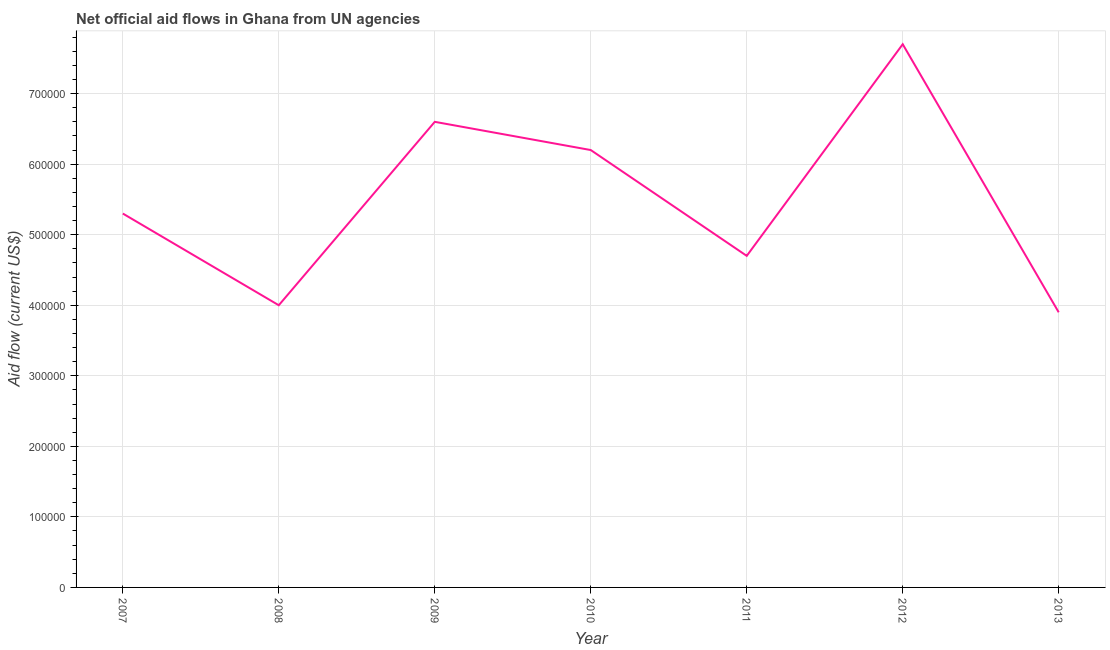What is the net official flows from un agencies in 2013?
Your response must be concise. 3.90e+05. Across all years, what is the maximum net official flows from un agencies?
Provide a short and direct response. 7.70e+05. Across all years, what is the minimum net official flows from un agencies?
Offer a terse response. 3.90e+05. In which year was the net official flows from un agencies maximum?
Provide a succinct answer. 2012. In which year was the net official flows from un agencies minimum?
Your answer should be compact. 2013. What is the sum of the net official flows from un agencies?
Your answer should be compact. 3.84e+06. What is the difference between the net official flows from un agencies in 2011 and 2013?
Offer a very short reply. 8.00e+04. What is the average net official flows from un agencies per year?
Your answer should be very brief. 5.49e+05. What is the median net official flows from un agencies?
Provide a short and direct response. 5.30e+05. What is the ratio of the net official flows from un agencies in 2009 to that in 2010?
Provide a short and direct response. 1.06. Is the net official flows from un agencies in 2007 less than that in 2010?
Your response must be concise. Yes. Is the difference between the net official flows from un agencies in 2009 and 2013 greater than the difference between any two years?
Offer a very short reply. No. What is the difference between the highest and the lowest net official flows from un agencies?
Give a very brief answer. 3.80e+05. In how many years, is the net official flows from un agencies greater than the average net official flows from un agencies taken over all years?
Offer a terse response. 3. Are the values on the major ticks of Y-axis written in scientific E-notation?
Make the answer very short. No. Does the graph contain any zero values?
Provide a succinct answer. No. Does the graph contain grids?
Provide a short and direct response. Yes. What is the title of the graph?
Give a very brief answer. Net official aid flows in Ghana from UN agencies. What is the label or title of the X-axis?
Your response must be concise. Year. What is the Aid flow (current US$) of 2007?
Give a very brief answer. 5.30e+05. What is the Aid flow (current US$) of 2008?
Your response must be concise. 4.00e+05. What is the Aid flow (current US$) in 2009?
Ensure brevity in your answer.  6.60e+05. What is the Aid flow (current US$) of 2010?
Your response must be concise. 6.20e+05. What is the Aid flow (current US$) of 2012?
Keep it short and to the point. 7.70e+05. What is the difference between the Aid flow (current US$) in 2007 and 2010?
Your response must be concise. -9.00e+04. What is the difference between the Aid flow (current US$) in 2007 and 2011?
Your answer should be very brief. 6.00e+04. What is the difference between the Aid flow (current US$) in 2007 and 2013?
Keep it short and to the point. 1.40e+05. What is the difference between the Aid flow (current US$) in 2008 and 2009?
Your answer should be very brief. -2.60e+05. What is the difference between the Aid flow (current US$) in 2008 and 2011?
Make the answer very short. -7.00e+04. What is the difference between the Aid flow (current US$) in 2008 and 2012?
Your response must be concise. -3.70e+05. What is the difference between the Aid flow (current US$) in 2009 and 2010?
Offer a very short reply. 4.00e+04. What is the difference between the Aid flow (current US$) in 2009 and 2012?
Provide a short and direct response. -1.10e+05. What is the difference between the Aid flow (current US$) in 2009 and 2013?
Your answer should be very brief. 2.70e+05. What is the difference between the Aid flow (current US$) in 2010 and 2013?
Make the answer very short. 2.30e+05. What is the difference between the Aid flow (current US$) in 2011 and 2012?
Provide a succinct answer. -3.00e+05. What is the difference between the Aid flow (current US$) in 2011 and 2013?
Offer a very short reply. 8.00e+04. What is the difference between the Aid flow (current US$) in 2012 and 2013?
Ensure brevity in your answer.  3.80e+05. What is the ratio of the Aid flow (current US$) in 2007 to that in 2008?
Your response must be concise. 1.32. What is the ratio of the Aid flow (current US$) in 2007 to that in 2009?
Offer a terse response. 0.8. What is the ratio of the Aid flow (current US$) in 2007 to that in 2010?
Offer a terse response. 0.85. What is the ratio of the Aid flow (current US$) in 2007 to that in 2011?
Offer a very short reply. 1.13. What is the ratio of the Aid flow (current US$) in 2007 to that in 2012?
Your answer should be very brief. 0.69. What is the ratio of the Aid flow (current US$) in 2007 to that in 2013?
Provide a succinct answer. 1.36. What is the ratio of the Aid flow (current US$) in 2008 to that in 2009?
Keep it short and to the point. 0.61. What is the ratio of the Aid flow (current US$) in 2008 to that in 2010?
Your answer should be compact. 0.65. What is the ratio of the Aid flow (current US$) in 2008 to that in 2011?
Make the answer very short. 0.85. What is the ratio of the Aid flow (current US$) in 2008 to that in 2012?
Your answer should be very brief. 0.52. What is the ratio of the Aid flow (current US$) in 2008 to that in 2013?
Offer a very short reply. 1.03. What is the ratio of the Aid flow (current US$) in 2009 to that in 2010?
Give a very brief answer. 1.06. What is the ratio of the Aid flow (current US$) in 2009 to that in 2011?
Make the answer very short. 1.4. What is the ratio of the Aid flow (current US$) in 2009 to that in 2012?
Keep it short and to the point. 0.86. What is the ratio of the Aid flow (current US$) in 2009 to that in 2013?
Ensure brevity in your answer.  1.69. What is the ratio of the Aid flow (current US$) in 2010 to that in 2011?
Offer a very short reply. 1.32. What is the ratio of the Aid flow (current US$) in 2010 to that in 2012?
Your response must be concise. 0.81. What is the ratio of the Aid flow (current US$) in 2010 to that in 2013?
Ensure brevity in your answer.  1.59. What is the ratio of the Aid flow (current US$) in 2011 to that in 2012?
Provide a short and direct response. 0.61. What is the ratio of the Aid flow (current US$) in 2011 to that in 2013?
Make the answer very short. 1.21. What is the ratio of the Aid flow (current US$) in 2012 to that in 2013?
Offer a very short reply. 1.97. 